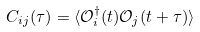<formula> <loc_0><loc_0><loc_500><loc_500>C _ { i j } ( \tau ) = \langle \mathcal { O } ^ { \dag } _ { i } ( t ) \mathcal { O } _ { j } ( t + \tau ) \rangle</formula> 